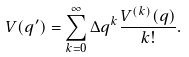Convert formula to latex. <formula><loc_0><loc_0><loc_500><loc_500>V ( q ^ { \prime } ) = \sum _ { k = 0 } ^ { \infty } \Delta q ^ { k } \frac { V ^ { ( k ) } ( q ) } { k ! } .</formula> 